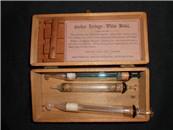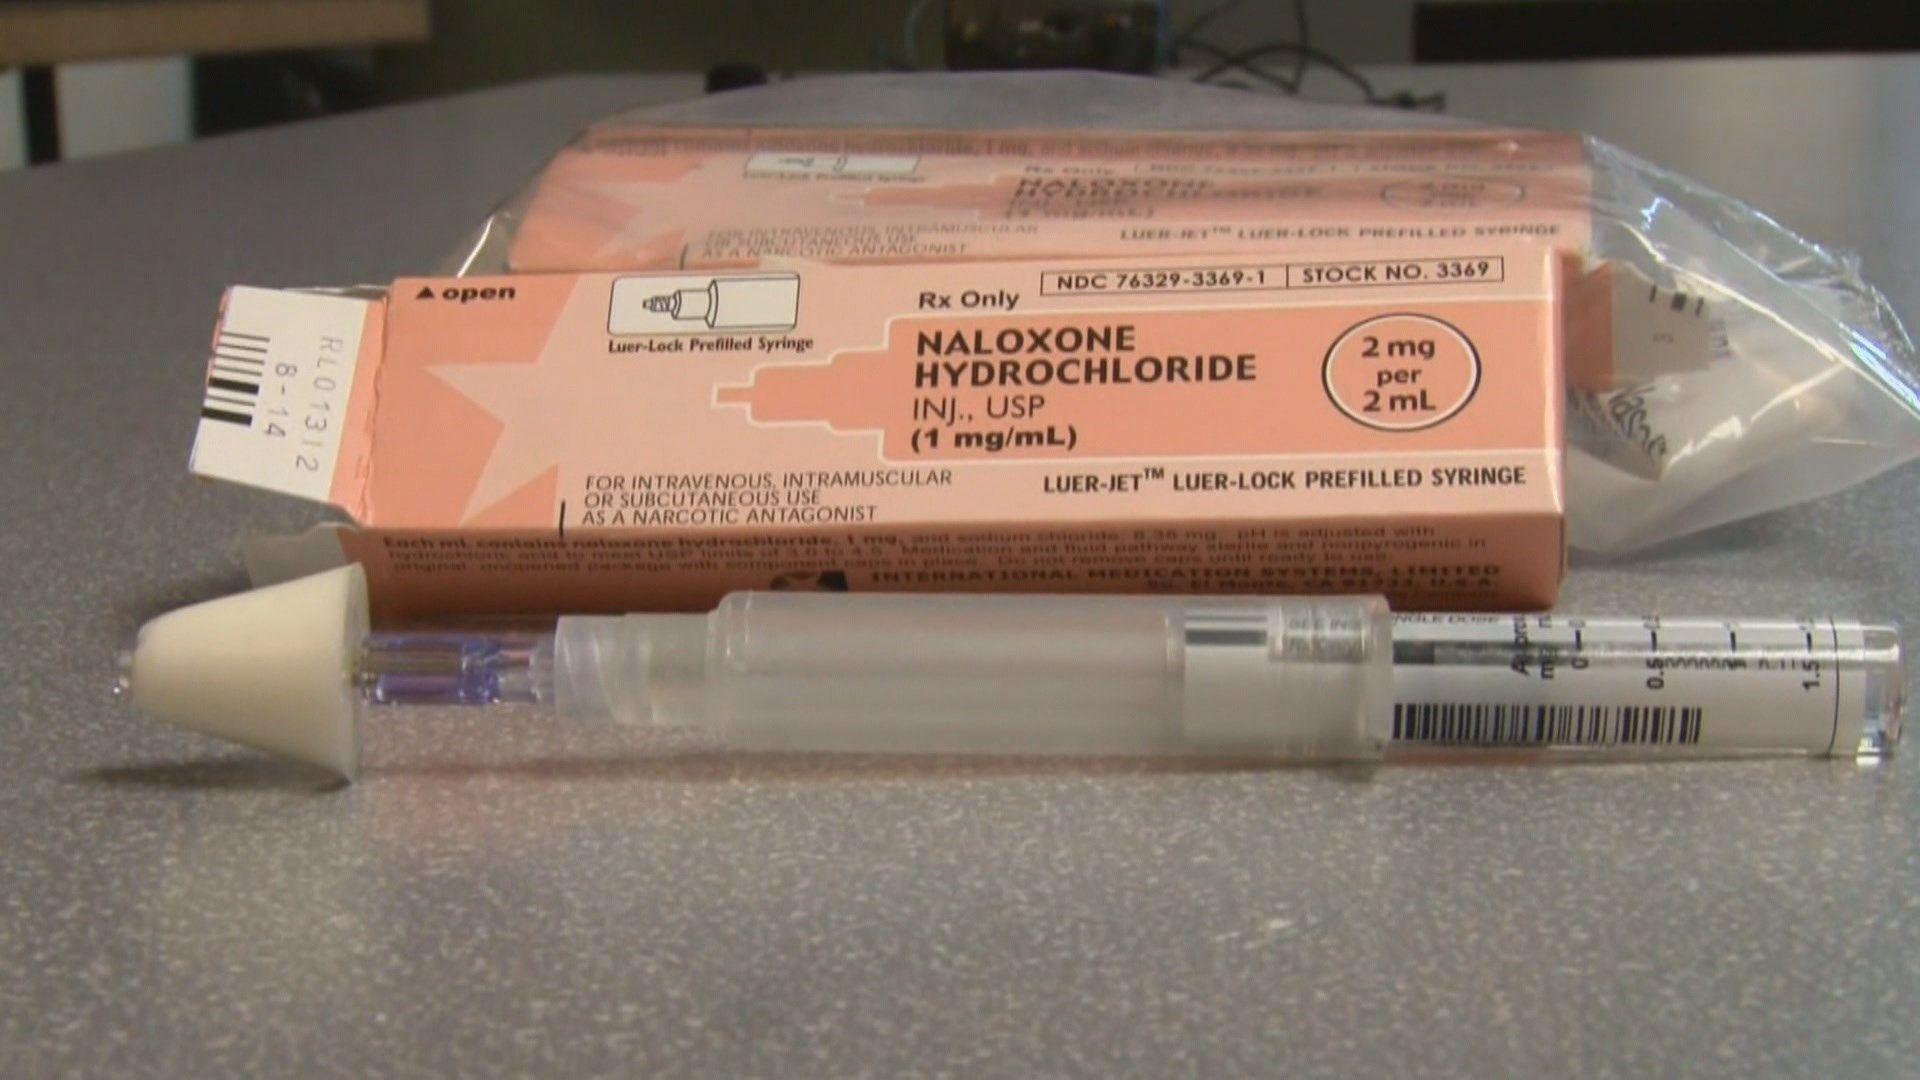The first image is the image on the left, the second image is the image on the right. Analyze the images presented: Is the assertion "An image shows one open rectangular metal case with syringe items inside of it." valid? Answer yes or no. No. The first image is the image on the left, the second image is the image on the right. For the images shown, is this caption "Syringes sit in front of yellow boxes in one of the images." true? Answer yes or no. No. 